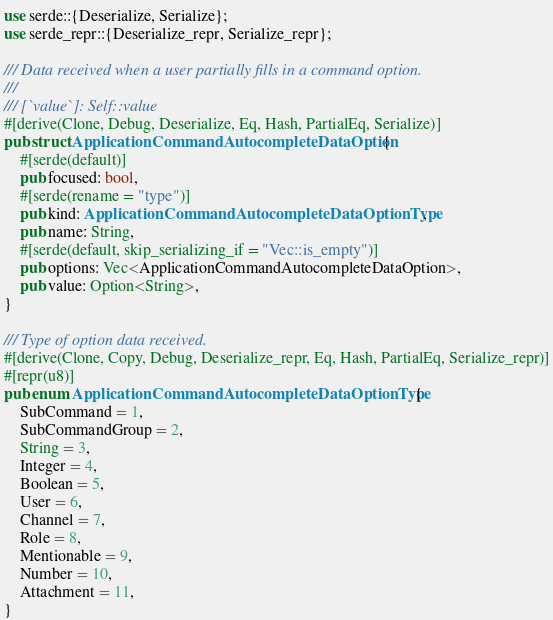<code> <loc_0><loc_0><loc_500><loc_500><_Rust_>use serde::{Deserialize, Serialize};
use serde_repr::{Deserialize_repr, Serialize_repr};

/// Data received when a user partially fills in a command option.
///
/// [`value`]: Self::value
#[derive(Clone, Debug, Deserialize, Eq, Hash, PartialEq, Serialize)]
pub struct ApplicationCommandAutocompleteDataOption {
    #[serde(default)]
    pub focused: bool,
    #[serde(rename = "type")]
    pub kind: ApplicationCommandAutocompleteDataOptionType,
    pub name: String,
    #[serde(default, skip_serializing_if = "Vec::is_empty")]
    pub options: Vec<ApplicationCommandAutocompleteDataOption>,
    pub value: Option<String>,
}

/// Type of option data received.
#[derive(Clone, Copy, Debug, Deserialize_repr, Eq, Hash, PartialEq, Serialize_repr)]
#[repr(u8)]
pub enum ApplicationCommandAutocompleteDataOptionType {
    SubCommand = 1,
    SubCommandGroup = 2,
    String = 3,
    Integer = 4,
    Boolean = 5,
    User = 6,
    Channel = 7,
    Role = 8,
    Mentionable = 9,
    Number = 10,
    Attachment = 11,
}
</code> 